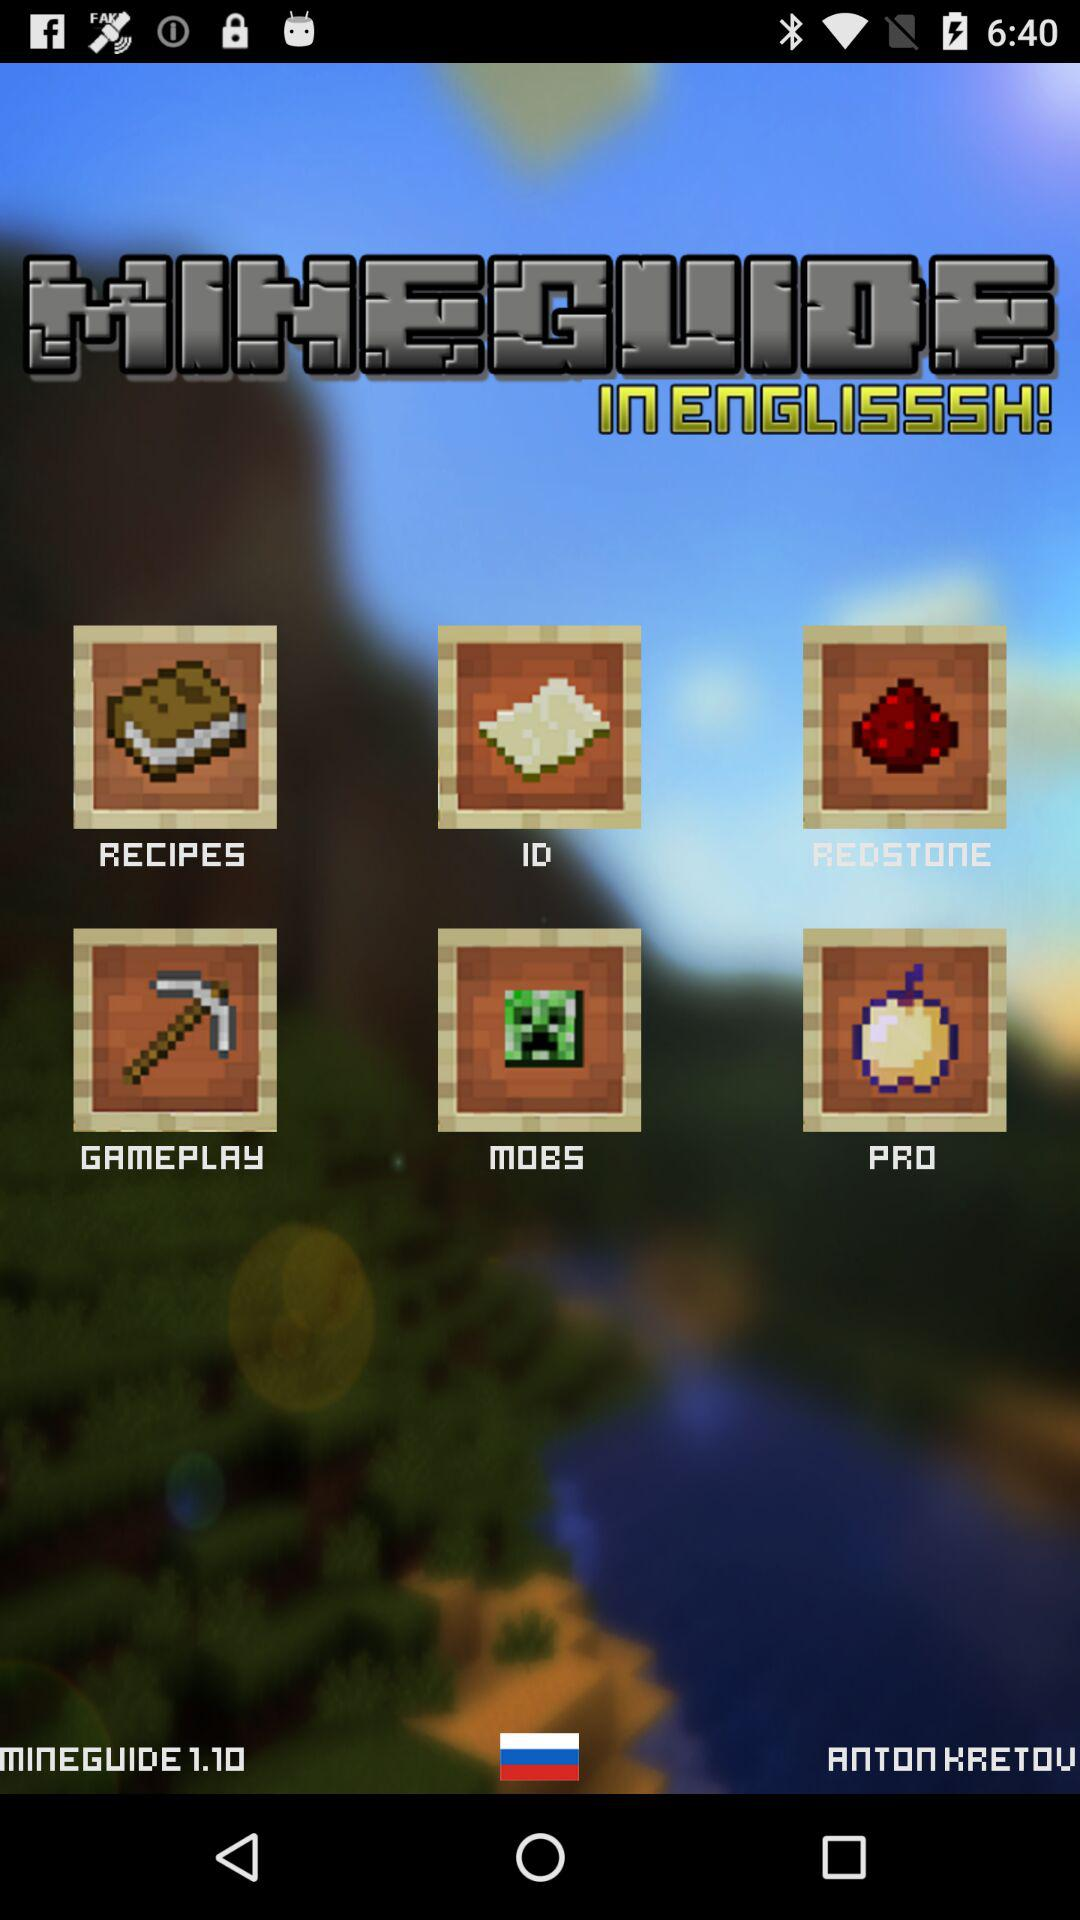What is the name of the application? The application name is "MINEGUIDE". 